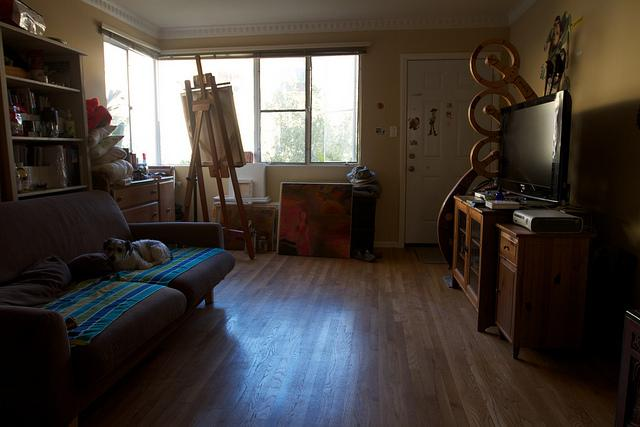What is likely on the item by the window? painting 